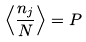Convert formula to latex. <formula><loc_0><loc_0><loc_500><loc_500>\left < \frac { n _ { j } } { N } \right > = P</formula> 